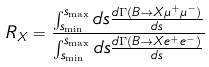Convert formula to latex. <formula><loc_0><loc_0><loc_500><loc_500>R _ { X } = \frac { \int _ { s _ { \min } } ^ { s _ { \max } } d s \frac { d \Gamma ( B \to X \mu ^ { + } \mu ^ { - } ) } { d s } } { \int _ { s _ { \min } } ^ { s _ { \max } } d s \frac { d \Gamma ( B \to X e ^ { + } e ^ { - } ) } { d s } }</formula> 